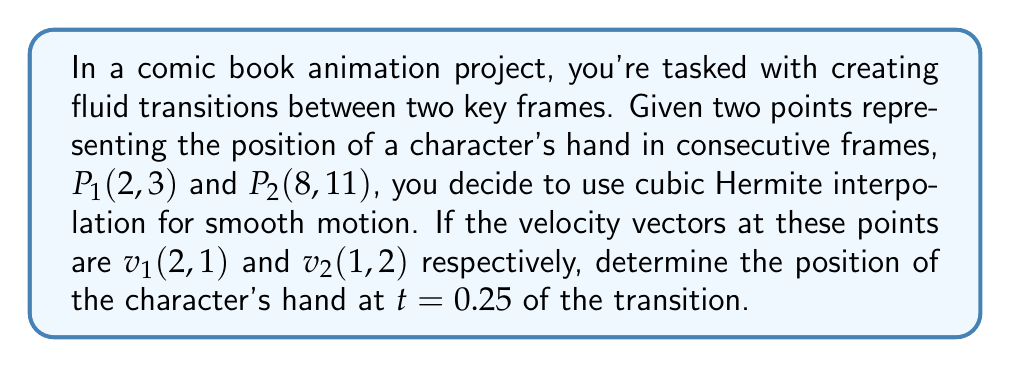Could you help me with this problem? To solve this problem, we'll use the cubic Hermite interpolation formula:

$$P(t) = (2t^3 - 3t^2 + 1)P_1 + (t^3 - 2t^2 + t)v_1 + (-2t^3 + 3t^2)P_2 + (t^3 - t^2)v_2$$

Where $t$ is the interpolation parameter ranging from 0 to 1.

Let's break down the solution step-by-step:

1) First, we need to calculate the basis functions for $t = 0.25$:
   
   $$h_{00} = 2t^3 - 3t^2 + 1 = 2(0.25)^3 - 3(0.25)^2 + 1 = 0.84375$$
   $$h_{10} = t^3 - 2t^2 + t = (0.25)^3 - 2(0.25)^2 + 0.25 = 0.15625$$
   $$h_{01} = -2t^3 + 3t^2 = -2(0.25)^3 + 3(0.25)^2 = 0.15625$$
   $$h_{11} = t^3 - t^2 = (0.25)^3 - (0.25)^2 = -0.046875$$

2) Now, we can substitute these values into the interpolation formula:

   $$P(0.25) = 0.84375P_1 + 0.15625v_1 + 0.15625P_2 - 0.046875v_2$$

3) Let's calculate each term:
   
   $$0.84375P_1 = 0.84375(2, 3) = (1.6875, 2.53125)$$
   $$0.15625v_1 = 0.15625(2, 1) = (0.3125, 0.15625)$$
   $$0.15625P_2 = 0.15625(8, 11) = (1.25, 1.71875)$$
   $$-0.046875v_2 = -0.046875(1, 2) = (-0.046875, -0.09375)$$

4) Sum up all these terms:
   
   $$P(0.25) = (1.6875 + 0.3125 + 1.25 - 0.046875, 2.53125 + 0.15625 + 1.71875 - 0.09375)$$
   $$P(0.25) = (3.203125, 4.3125)$$

Therefore, the position of the character's hand at $t = 0.25$ of the transition is (3.203125, 4.3125).
Answer: (3.203125, 4.3125) 